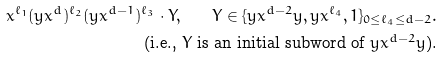Convert formula to latex. <formula><loc_0><loc_0><loc_500><loc_500>x ^ { \ell _ { 1 } } ( y x ^ { d } ) ^ { \ell _ { 2 } } ( y x ^ { d - 1 } ) ^ { \ell _ { 3 } } \cdot Y , \quad Y \in \{ y x ^ { d - 2 } y , y x ^ { \ell _ { 4 } } , 1 \} _ { 0 \leq \ell _ { 4 } \leq d - 2 } . \\ \text { (i.e., $Y$ is an initial subword of $yx^{d-2} y$).}</formula> 